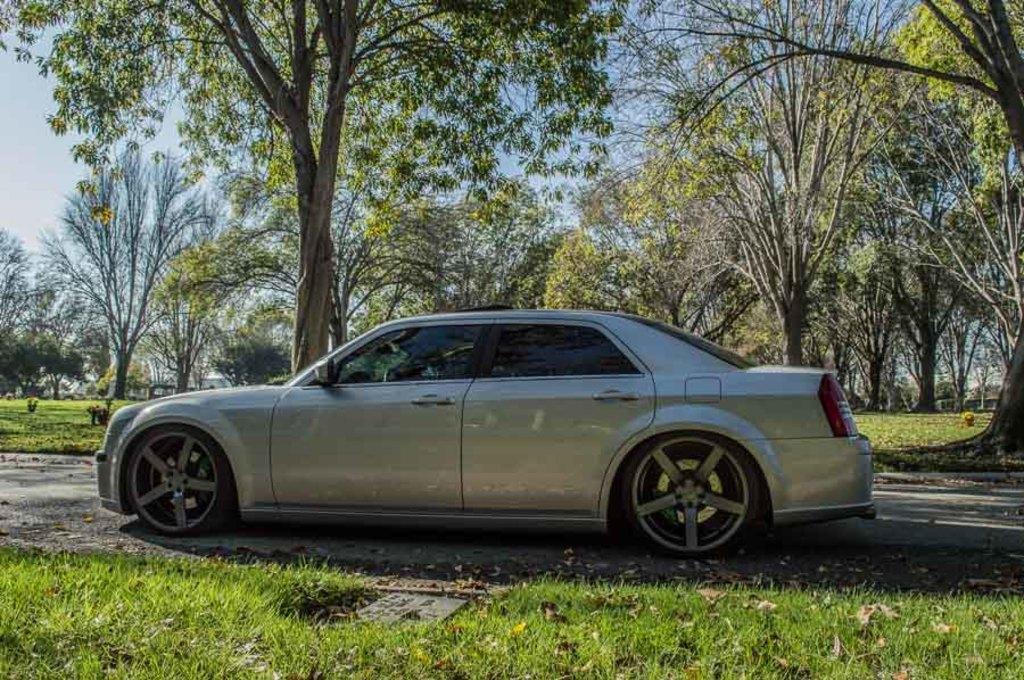Please provide a concise description of this image. In this picture there is a grey car which is parked near to the grass. In the background I can see many trees and plants. At the top I can see the sky and clouds. 